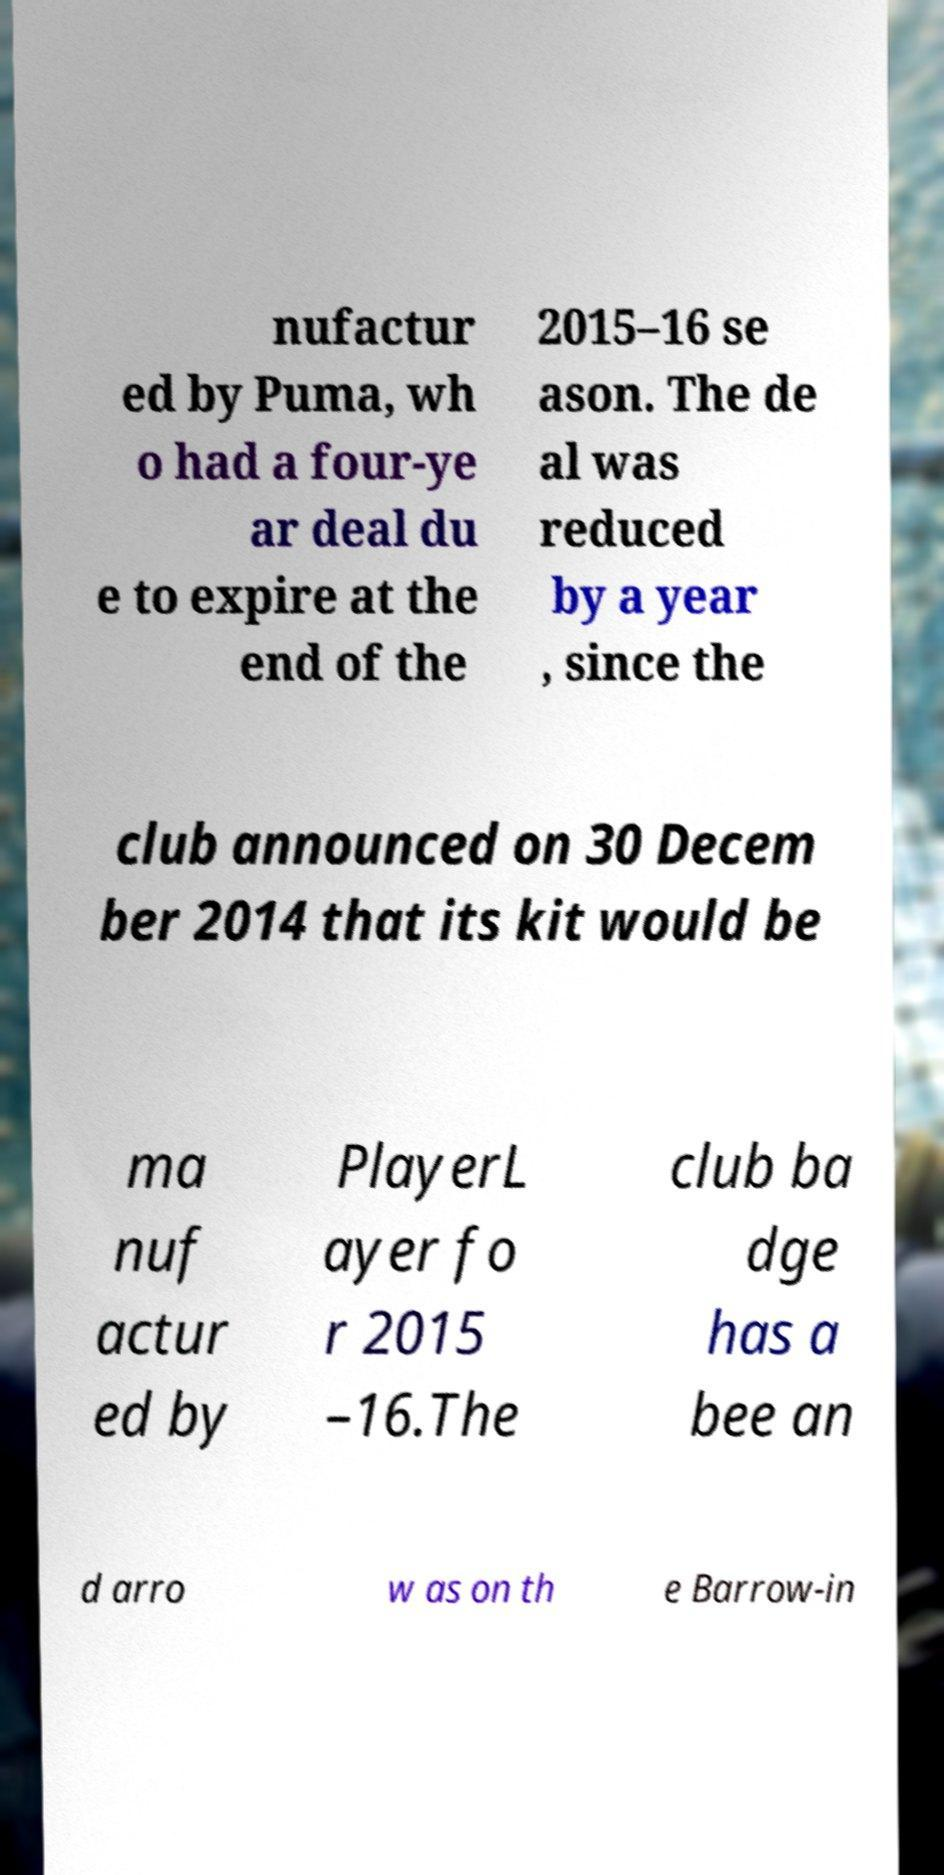There's text embedded in this image that I need extracted. Can you transcribe it verbatim? nufactur ed by Puma, wh o had a four-ye ar deal du e to expire at the end of the 2015–16 se ason. The de al was reduced by a year , since the club announced on 30 Decem ber 2014 that its kit would be ma nuf actur ed by PlayerL ayer fo r 2015 –16.The club ba dge has a bee an d arro w as on th e Barrow-in 